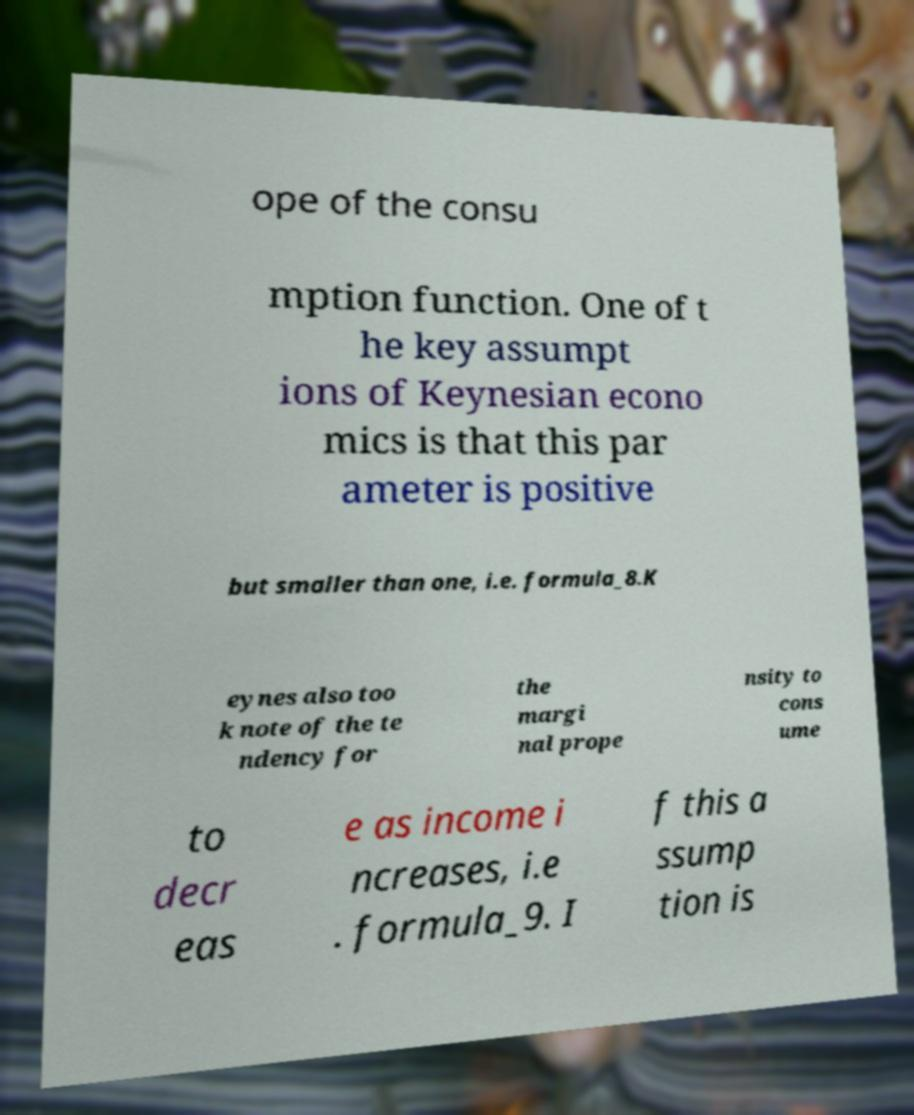Could you extract and type out the text from this image? ope of the consu mption function. One of t he key assumpt ions of Keynesian econo mics is that this par ameter is positive but smaller than one, i.e. formula_8.K eynes also too k note of the te ndency for the margi nal prope nsity to cons ume to decr eas e as income i ncreases, i.e . formula_9. I f this a ssump tion is 